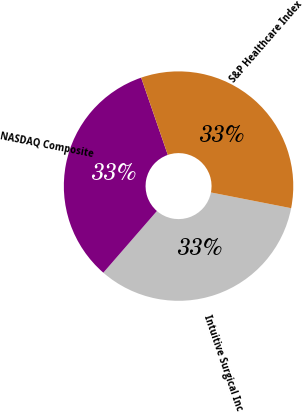Convert chart to OTSL. <chart><loc_0><loc_0><loc_500><loc_500><pie_chart><fcel>Intuitive Surgical Inc<fcel>NASDAQ Composite<fcel>S&P Healthcare Index<nl><fcel>33.3%<fcel>33.33%<fcel>33.37%<nl></chart> 